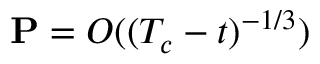Convert formula to latex. <formula><loc_0><loc_0><loc_500><loc_500>P = O ( ( T _ { c } - t ) ^ { - 1 / 3 } )</formula> 